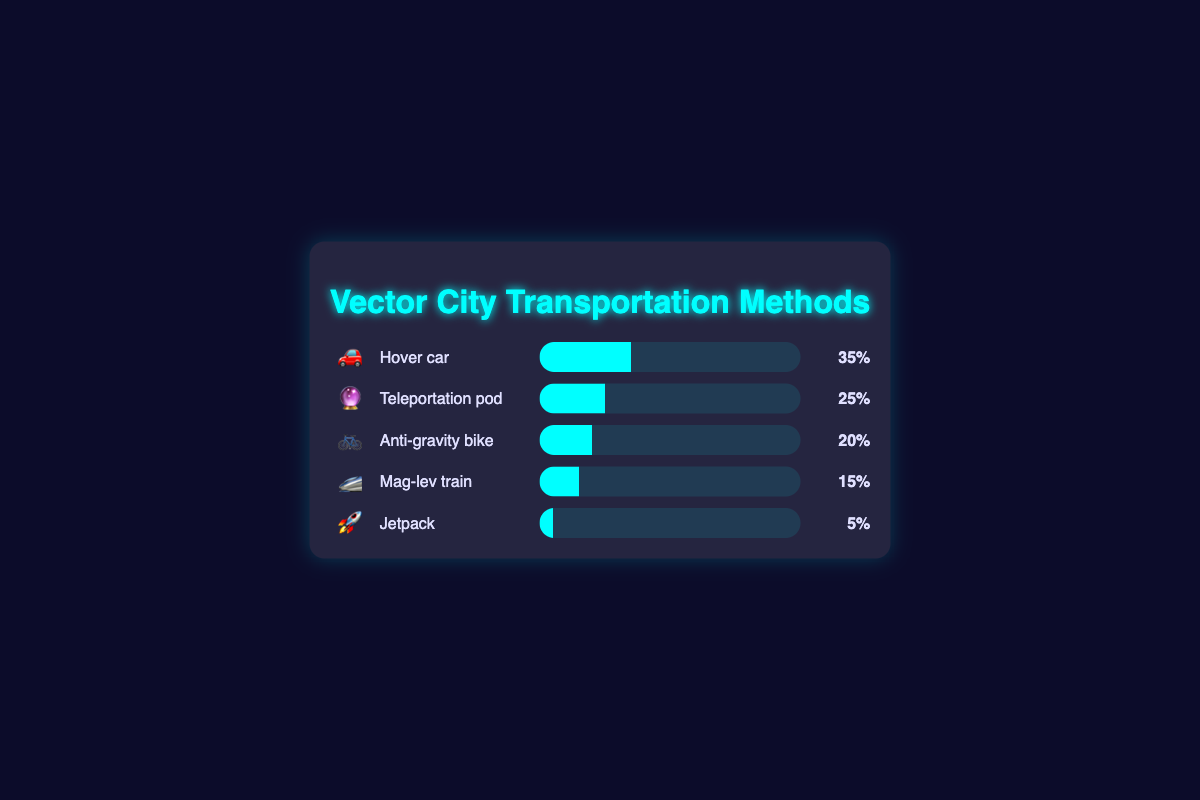What are the top three most common transportation methods in Vector City? The top three transportation methods can be identified by their percentages: Hover car (35%), Teleportation pod (25%), and Anti-gravity bike (20%).
Answer: Hover car, Teleportation pod, Anti-gravity bike Which transportation method has the smallest percentage? By looking at the percentages, Jetpack has the smallest percentage at 5%.
Answer: Jetpack What is the combined percentage of the top two transportation methods? The top two transportation methods are Hover car (35%) and Teleportation pod (25%). Summing these gives 35% + 25% = 60%.
Answer: 60% How much more popular is the Hover car compared to the Anti-gravity bike? Hover car is used by 35% of people and Anti-gravity bike by 20%. The difference is 35% - 20% = 15%.
Answer: 15% Which transportation method is represented by the emoji 🔮? Looking at the figure, the Teleportation pod is represented by the emoji 🔮.
Answer: Teleportation pod How many transportation methods are listed in the chart? By counting the different bars (Hover car, Teleportation pod, Anti-gravity bike, Mag-lev train, and Jetpack), there are 5 transportation methods.
Answer: 5 Is the percentage of Mag-lev train usage more than twice the Jetpack usage? Mag-lev train usage is 15% while Jetpack usage is 5%. Twice the Jetpack usage would be 10%, and 15% is greater than 10%.
Answer: Yes Rank the transportation methods from least to most common. The percentages in ascending order are: Jetpack (5%), Mag-lev train (15%), Anti-gravity bike (20%), Teleportation pod (25%), and Hover car (35%).
Answer: Jetpack, Mag-lev train, Anti-gravity bike, Teleportation pod, Hover car What percentage of people do not use either Hover car or Teleportation pod? If 35% use Hover car and 25% use Teleportation pod, then 60% use these two methods. The remaining percentage is 100% - 60% = 40%.
Answer: 40% 